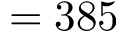<formula> <loc_0><loc_0><loc_500><loc_500>= 3 8 5</formula> 